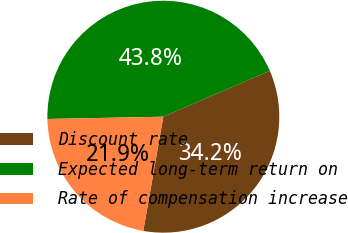<chart> <loc_0><loc_0><loc_500><loc_500><pie_chart><fcel>Discount rate<fcel>Expected long-term return on<fcel>Rate of compensation increase<nl><fcel>34.25%<fcel>43.84%<fcel>21.92%<nl></chart> 